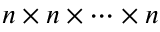Convert formula to latex. <formula><loc_0><loc_0><loc_500><loc_500>n \times n \times \cdots \times n</formula> 